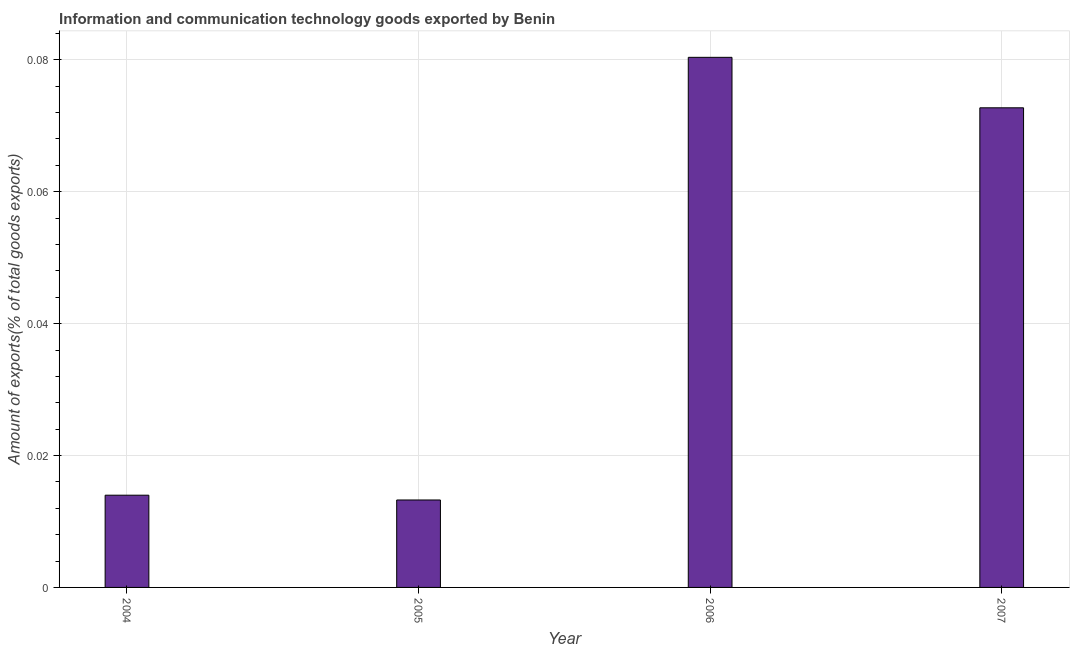Does the graph contain any zero values?
Offer a very short reply. No. Does the graph contain grids?
Offer a terse response. Yes. What is the title of the graph?
Your answer should be very brief. Information and communication technology goods exported by Benin. What is the label or title of the Y-axis?
Make the answer very short. Amount of exports(% of total goods exports). What is the amount of ict goods exports in 2006?
Provide a short and direct response. 0.08. Across all years, what is the maximum amount of ict goods exports?
Offer a very short reply. 0.08. Across all years, what is the minimum amount of ict goods exports?
Make the answer very short. 0.01. In which year was the amount of ict goods exports maximum?
Provide a succinct answer. 2006. In which year was the amount of ict goods exports minimum?
Make the answer very short. 2005. What is the sum of the amount of ict goods exports?
Give a very brief answer. 0.18. What is the difference between the amount of ict goods exports in 2006 and 2007?
Give a very brief answer. 0.01. What is the average amount of ict goods exports per year?
Your response must be concise. 0.04. What is the median amount of ict goods exports?
Keep it short and to the point. 0.04. In how many years, is the amount of ict goods exports greater than 0.052 %?
Provide a short and direct response. 2. Do a majority of the years between 2004 and 2005 (inclusive) have amount of ict goods exports greater than 0.028 %?
Offer a terse response. No. What is the ratio of the amount of ict goods exports in 2004 to that in 2006?
Keep it short and to the point. 0.17. What is the difference between the highest and the second highest amount of ict goods exports?
Offer a very short reply. 0.01. What is the difference between the highest and the lowest amount of ict goods exports?
Give a very brief answer. 0.07. Are all the bars in the graph horizontal?
Provide a short and direct response. No. Are the values on the major ticks of Y-axis written in scientific E-notation?
Make the answer very short. No. What is the Amount of exports(% of total goods exports) in 2004?
Provide a succinct answer. 0.01. What is the Amount of exports(% of total goods exports) in 2005?
Provide a succinct answer. 0.01. What is the Amount of exports(% of total goods exports) in 2006?
Make the answer very short. 0.08. What is the Amount of exports(% of total goods exports) in 2007?
Offer a very short reply. 0.07. What is the difference between the Amount of exports(% of total goods exports) in 2004 and 2005?
Your answer should be compact. 0. What is the difference between the Amount of exports(% of total goods exports) in 2004 and 2006?
Your answer should be very brief. -0.07. What is the difference between the Amount of exports(% of total goods exports) in 2004 and 2007?
Provide a short and direct response. -0.06. What is the difference between the Amount of exports(% of total goods exports) in 2005 and 2006?
Your answer should be compact. -0.07. What is the difference between the Amount of exports(% of total goods exports) in 2005 and 2007?
Provide a succinct answer. -0.06. What is the difference between the Amount of exports(% of total goods exports) in 2006 and 2007?
Your answer should be compact. 0.01. What is the ratio of the Amount of exports(% of total goods exports) in 2004 to that in 2005?
Provide a short and direct response. 1.05. What is the ratio of the Amount of exports(% of total goods exports) in 2004 to that in 2006?
Ensure brevity in your answer.  0.17. What is the ratio of the Amount of exports(% of total goods exports) in 2004 to that in 2007?
Offer a terse response. 0.19. What is the ratio of the Amount of exports(% of total goods exports) in 2005 to that in 2006?
Ensure brevity in your answer.  0.17. What is the ratio of the Amount of exports(% of total goods exports) in 2005 to that in 2007?
Give a very brief answer. 0.18. What is the ratio of the Amount of exports(% of total goods exports) in 2006 to that in 2007?
Make the answer very short. 1.1. 